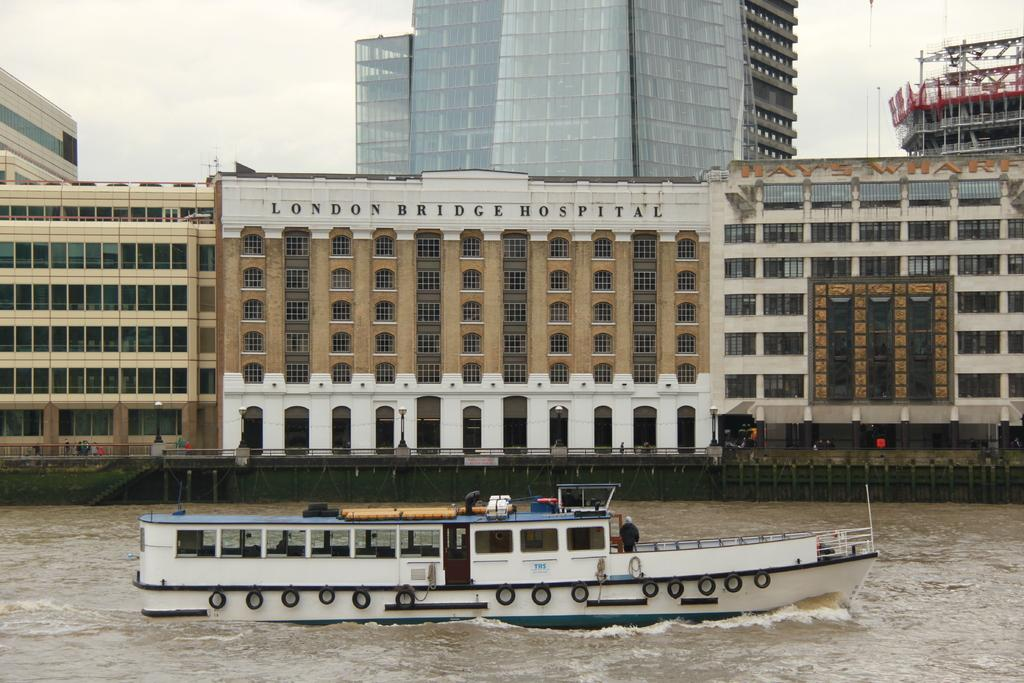<image>
Create a compact narrative representing the image presented. Waterfront view of London Hospital and Hay's Wharf. 